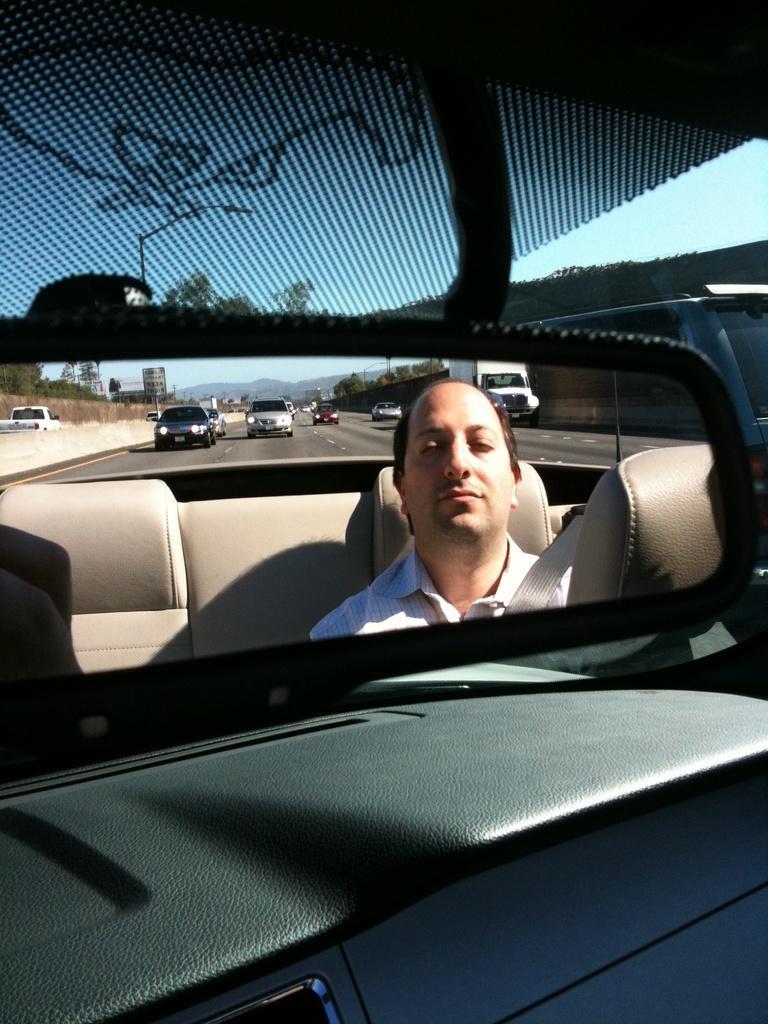Could you give a brief overview of what you see in this image? in the picture a person is driving a car on the road there are many cars on the road here we can see a clear sky. 